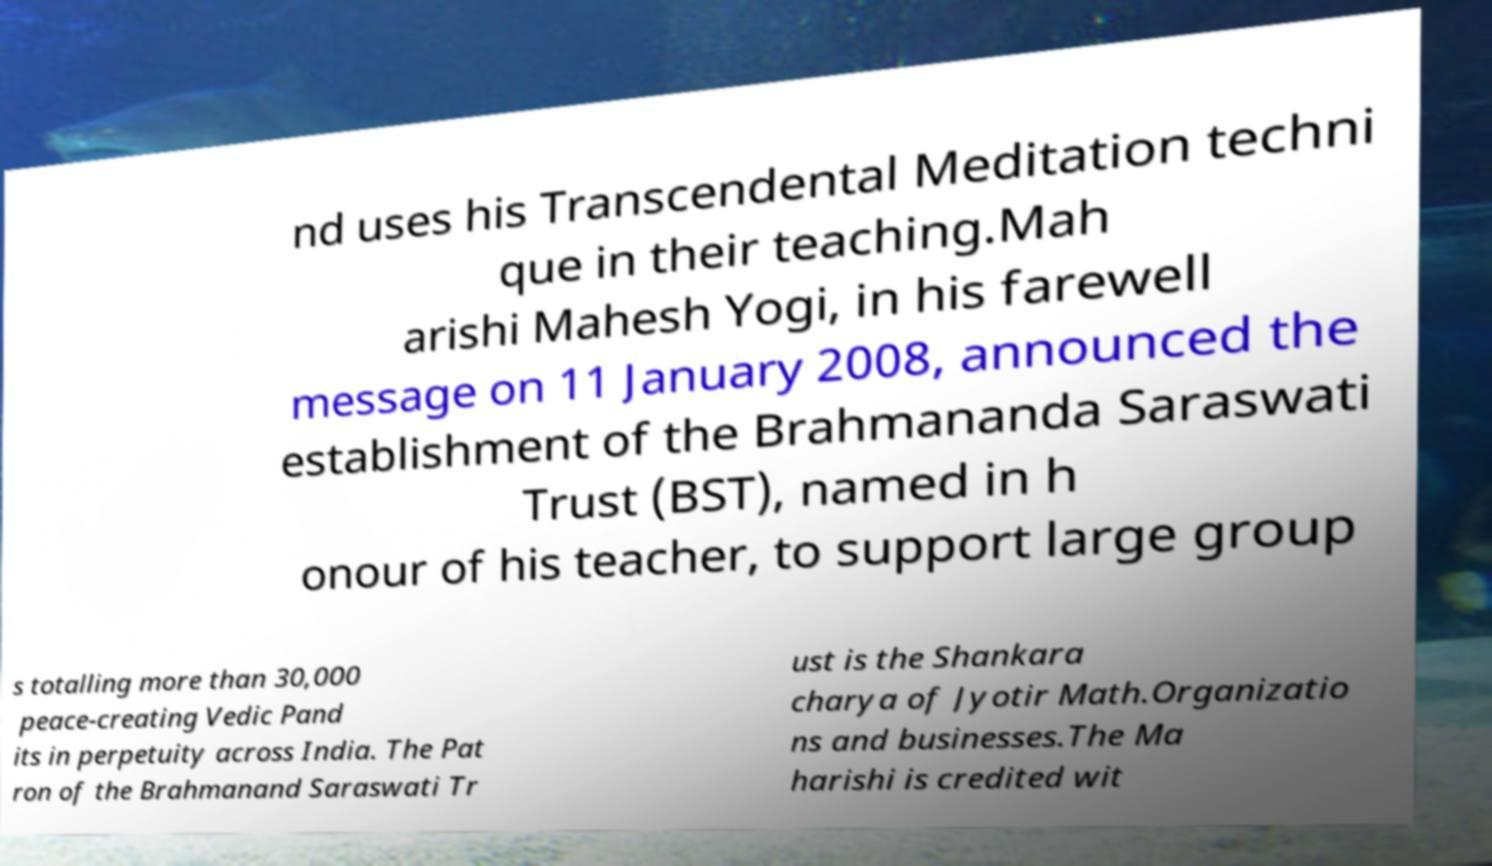Could you assist in decoding the text presented in this image and type it out clearly? nd uses his Transcendental Meditation techni que in their teaching.Mah arishi Mahesh Yogi, in his farewell message on 11 January 2008, announced the establishment of the Brahmananda Saraswati Trust (BST), named in h onour of his teacher, to support large group s totalling more than 30,000 peace-creating Vedic Pand its in perpetuity across India. The Pat ron of the Brahmanand Saraswati Tr ust is the Shankara charya of Jyotir Math.Organizatio ns and businesses.The Ma harishi is credited wit 